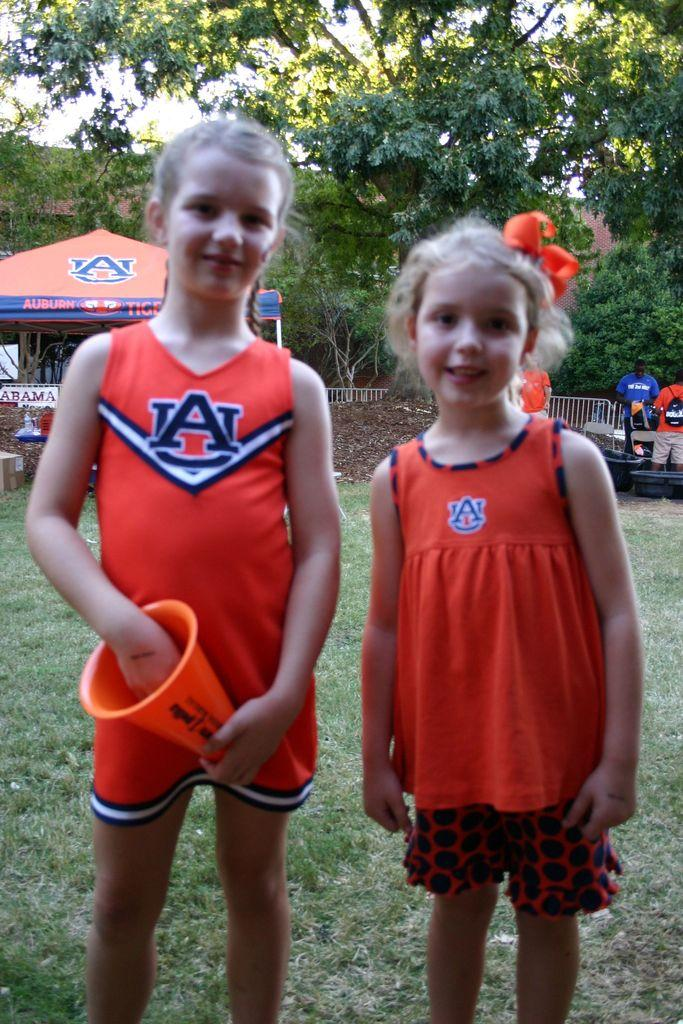<image>
Summarize the visual content of the image. Two girls are wearing Auburn outfits in orange and blue. 